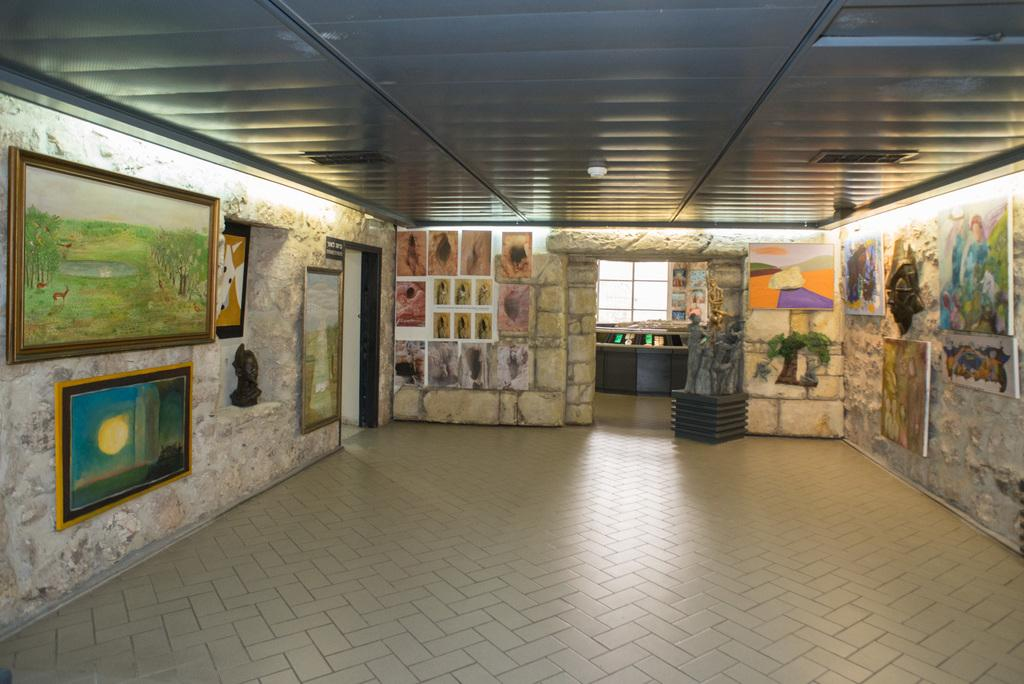What is present on the walls in the image? There are frames and boards on the walls in the image. What part of the room is visible in the image? The ceiling, floor, and walls are visible in the image. Can you describe the objects in the image? There are objects present in the image, but their specific nature is not mentioned in the provided facts. How many lizards are sitting on the twig in the image? There is no twig or lizards present in the image. What is the hope of the person in the image? There is no person present in the image, so it is impossible to determine their hope. 